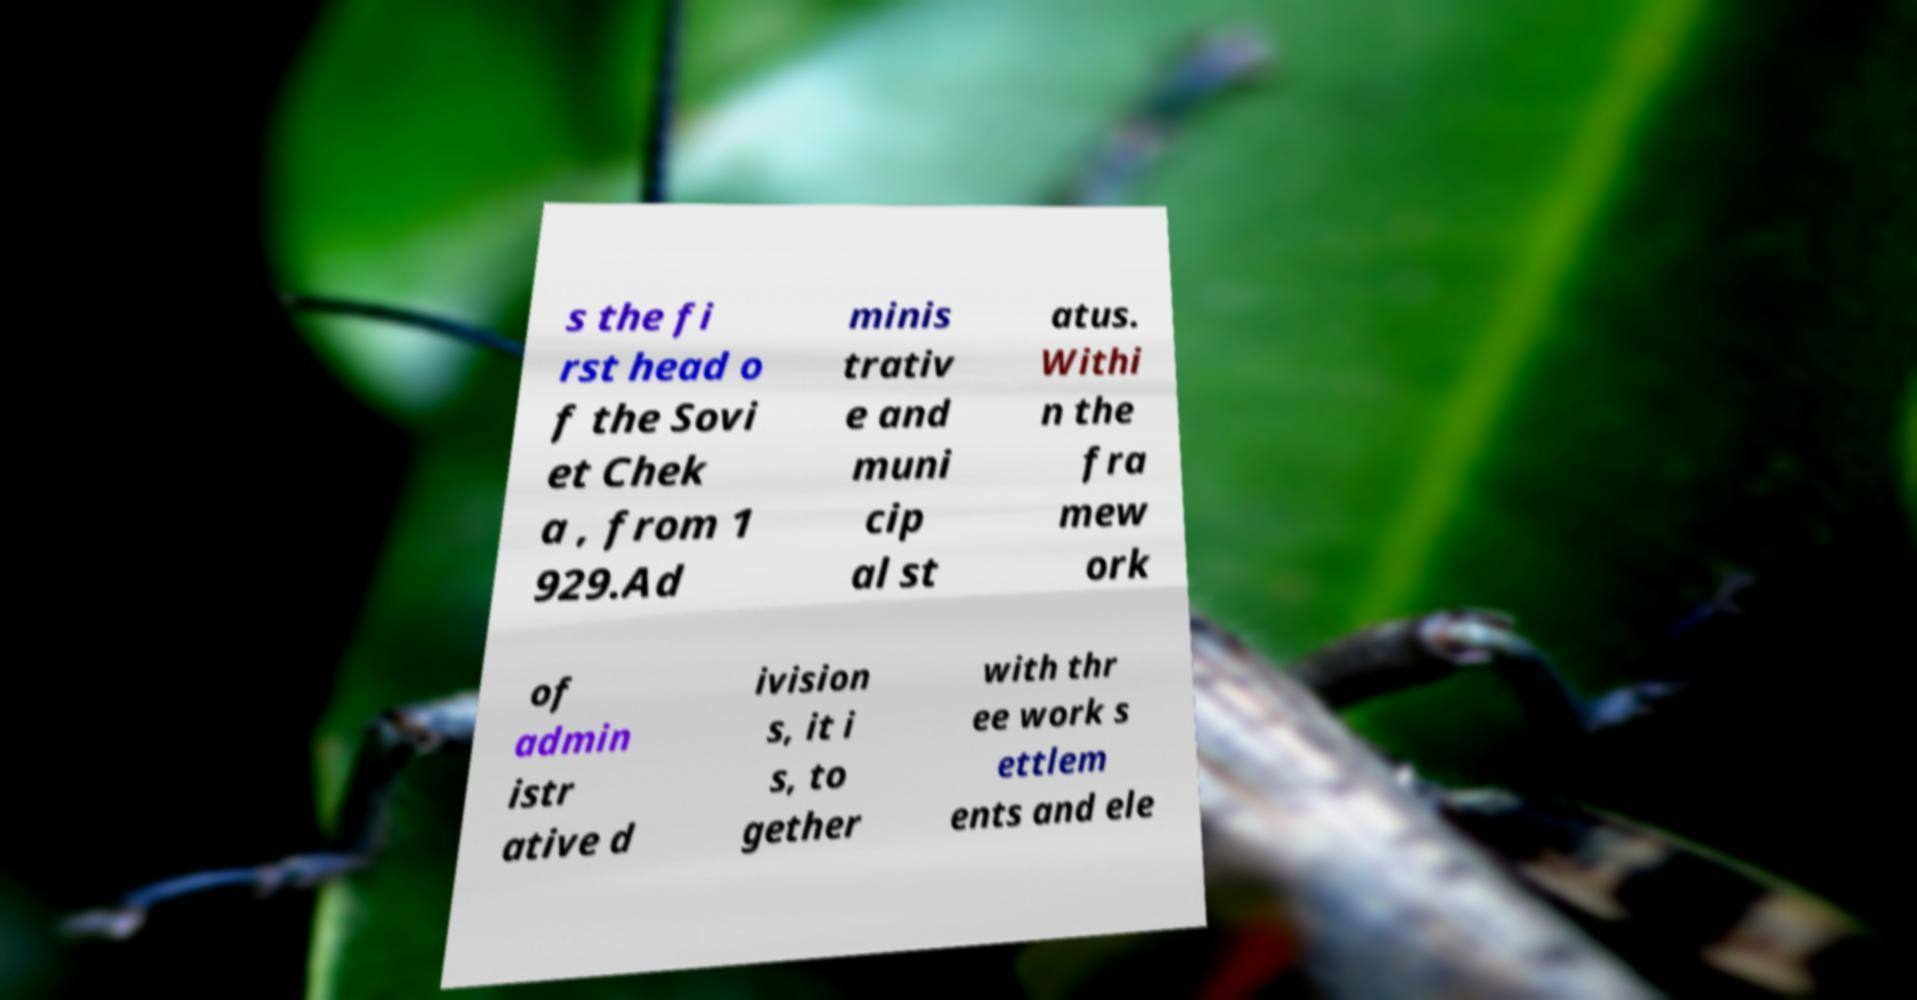Could you extract and type out the text from this image? s the fi rst head o f the Sovi et Chek a , from 1 929.Ad minis trativ e and muni cip al st atus. Withi n the fra mew ork of admin istr ative d ivision s, it i s, to gether with thr ee work s ettlem ents and ele 